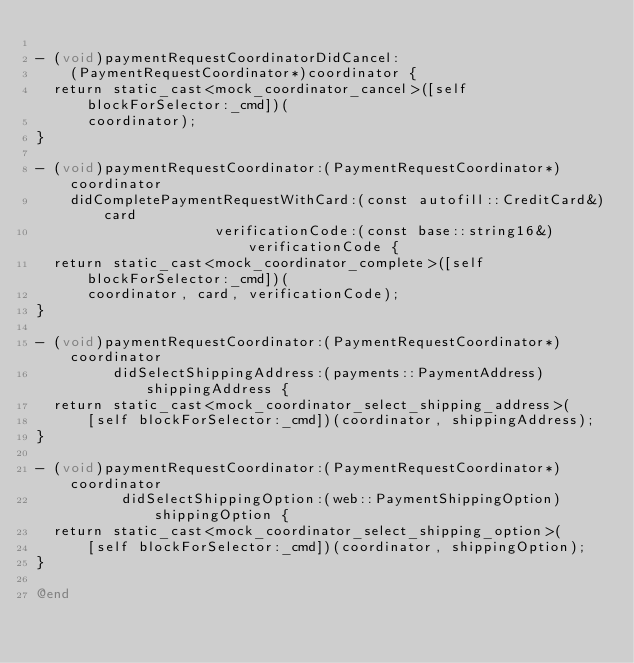<code> <loc_0><loc_0><loc_500><loc_500><_ObjectiveC_>
- (void)paymentRequestCoordinatorDidCancel:
    (PaymentRequestCoordinator*)coordinator {
  return static_cast<mock_coordinator_cancel>([self blockForSelector:_cmd])(
      coordinator);
}

- (void)paymentRequestCoordinator:(PaymentRequestCoordinator*)coordinator
    didCompletePaymentRequestWithCard:(const autofill::CreditCard&)card
                     verificationCode:(const base::string16&)verificationCode {
  return static_cast<mock_coordinator_complete>([self blockForSelector:_cmd])(
      coordinator, card, verificationCode);
}

- (void)paymentRequestCoordinator:(PaymentRequestCoordinator*)coordinator
         didSelectShippingAddress:(payments::PaymentAddress)shippingAddress {
  return static_cast<mock_coordinator_select_shipping_address>(
      [self blockForSelector:_cmd])(coordinator, shippingAddress);
}

- (void)paymentRequestCoordinator:(PaymentRequestCoordinator*)coordinator
          didSelectShippingOption:(web::PaymentShippingOption)shippingOption {
  return static_cast<mock_coordinator_select_shipping_option>(
      [self blockForSelector:_cmd])(coordinator, shippingOption);
}

@end
</code> 